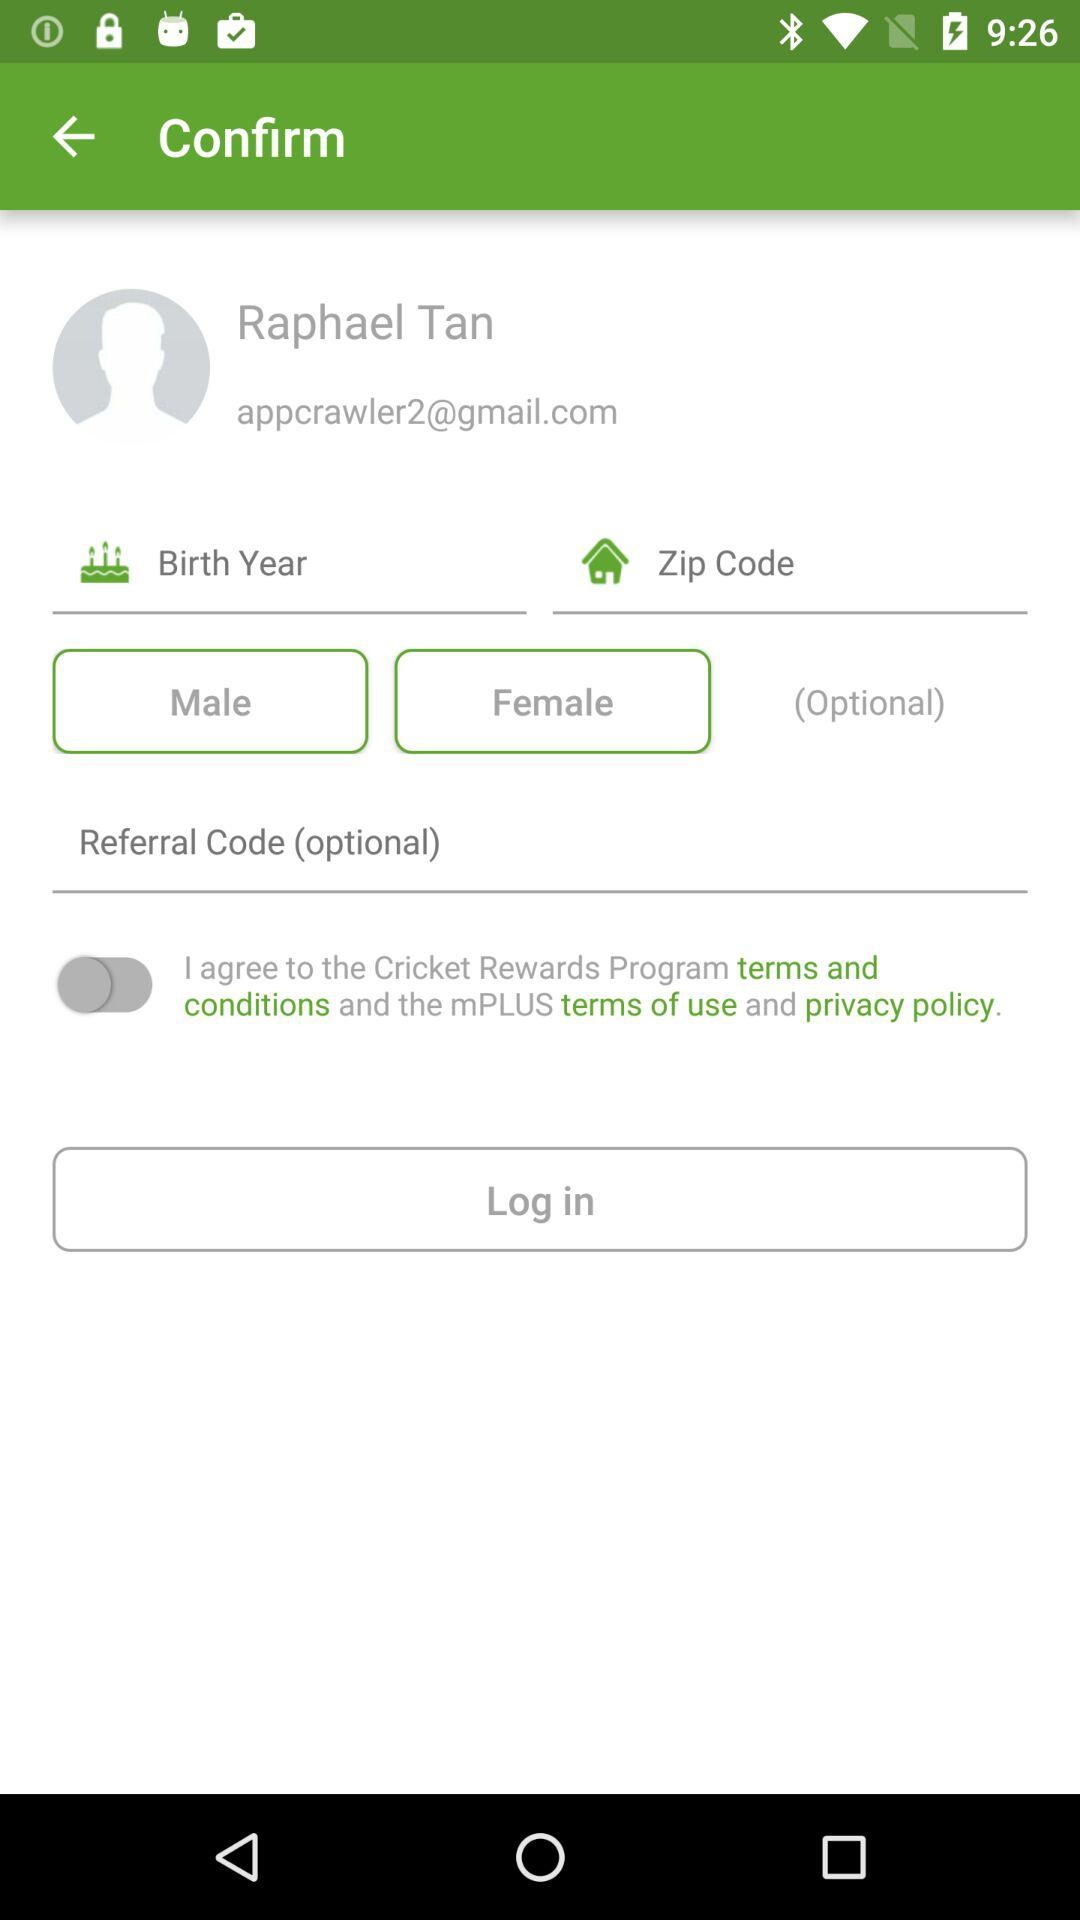What is the name of the user? The name of the user is Raphael Tan. 